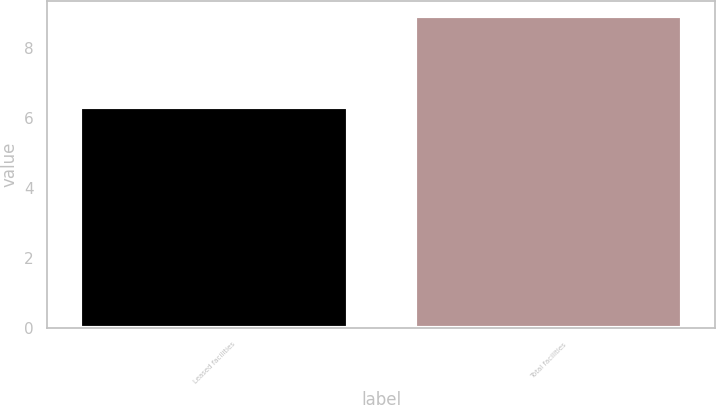Convert chart. <chart><loc_0><loc_0><loc_500><loc_500><bar_chart><fcel>Leased facilities<fcel>Total facilities<nl><fcel>6.3<fcel>8.9<nl></chart> 